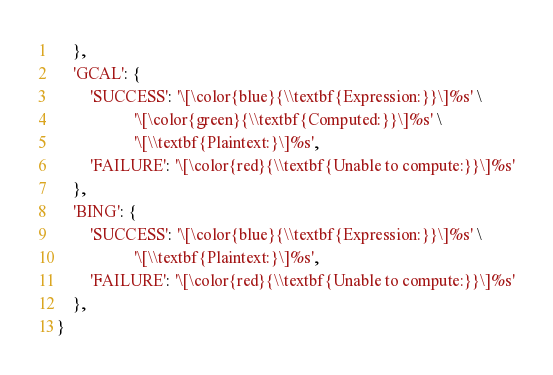<code> <loc_0><loc_0><loc_500><loc_500><_Python_>    },
    'GCAL': {
        'SUCCESS': '\[\color{blue}{\\textbf{Expression:}}\]%s' \
                   '\[\color{green}{\\textbf{Computed:}}\]%s' \
                   '\[\\textbf{Plaintext:}\]%s',
        'FAILURE': '\[\color{red}{\\textbf{Unable to compute:}}\]%s'
    },
    'BING': {
        'SUCCESS': '\[\color{blue}{\\textbf{Expression:}}\]%s' \
                   '\[\\textbf{Plaintext:}\]%s',
        'FAILURE': '\[\color{red}{\\textbf{Unable to compute:}}\]%s'
    },
}
</code> 